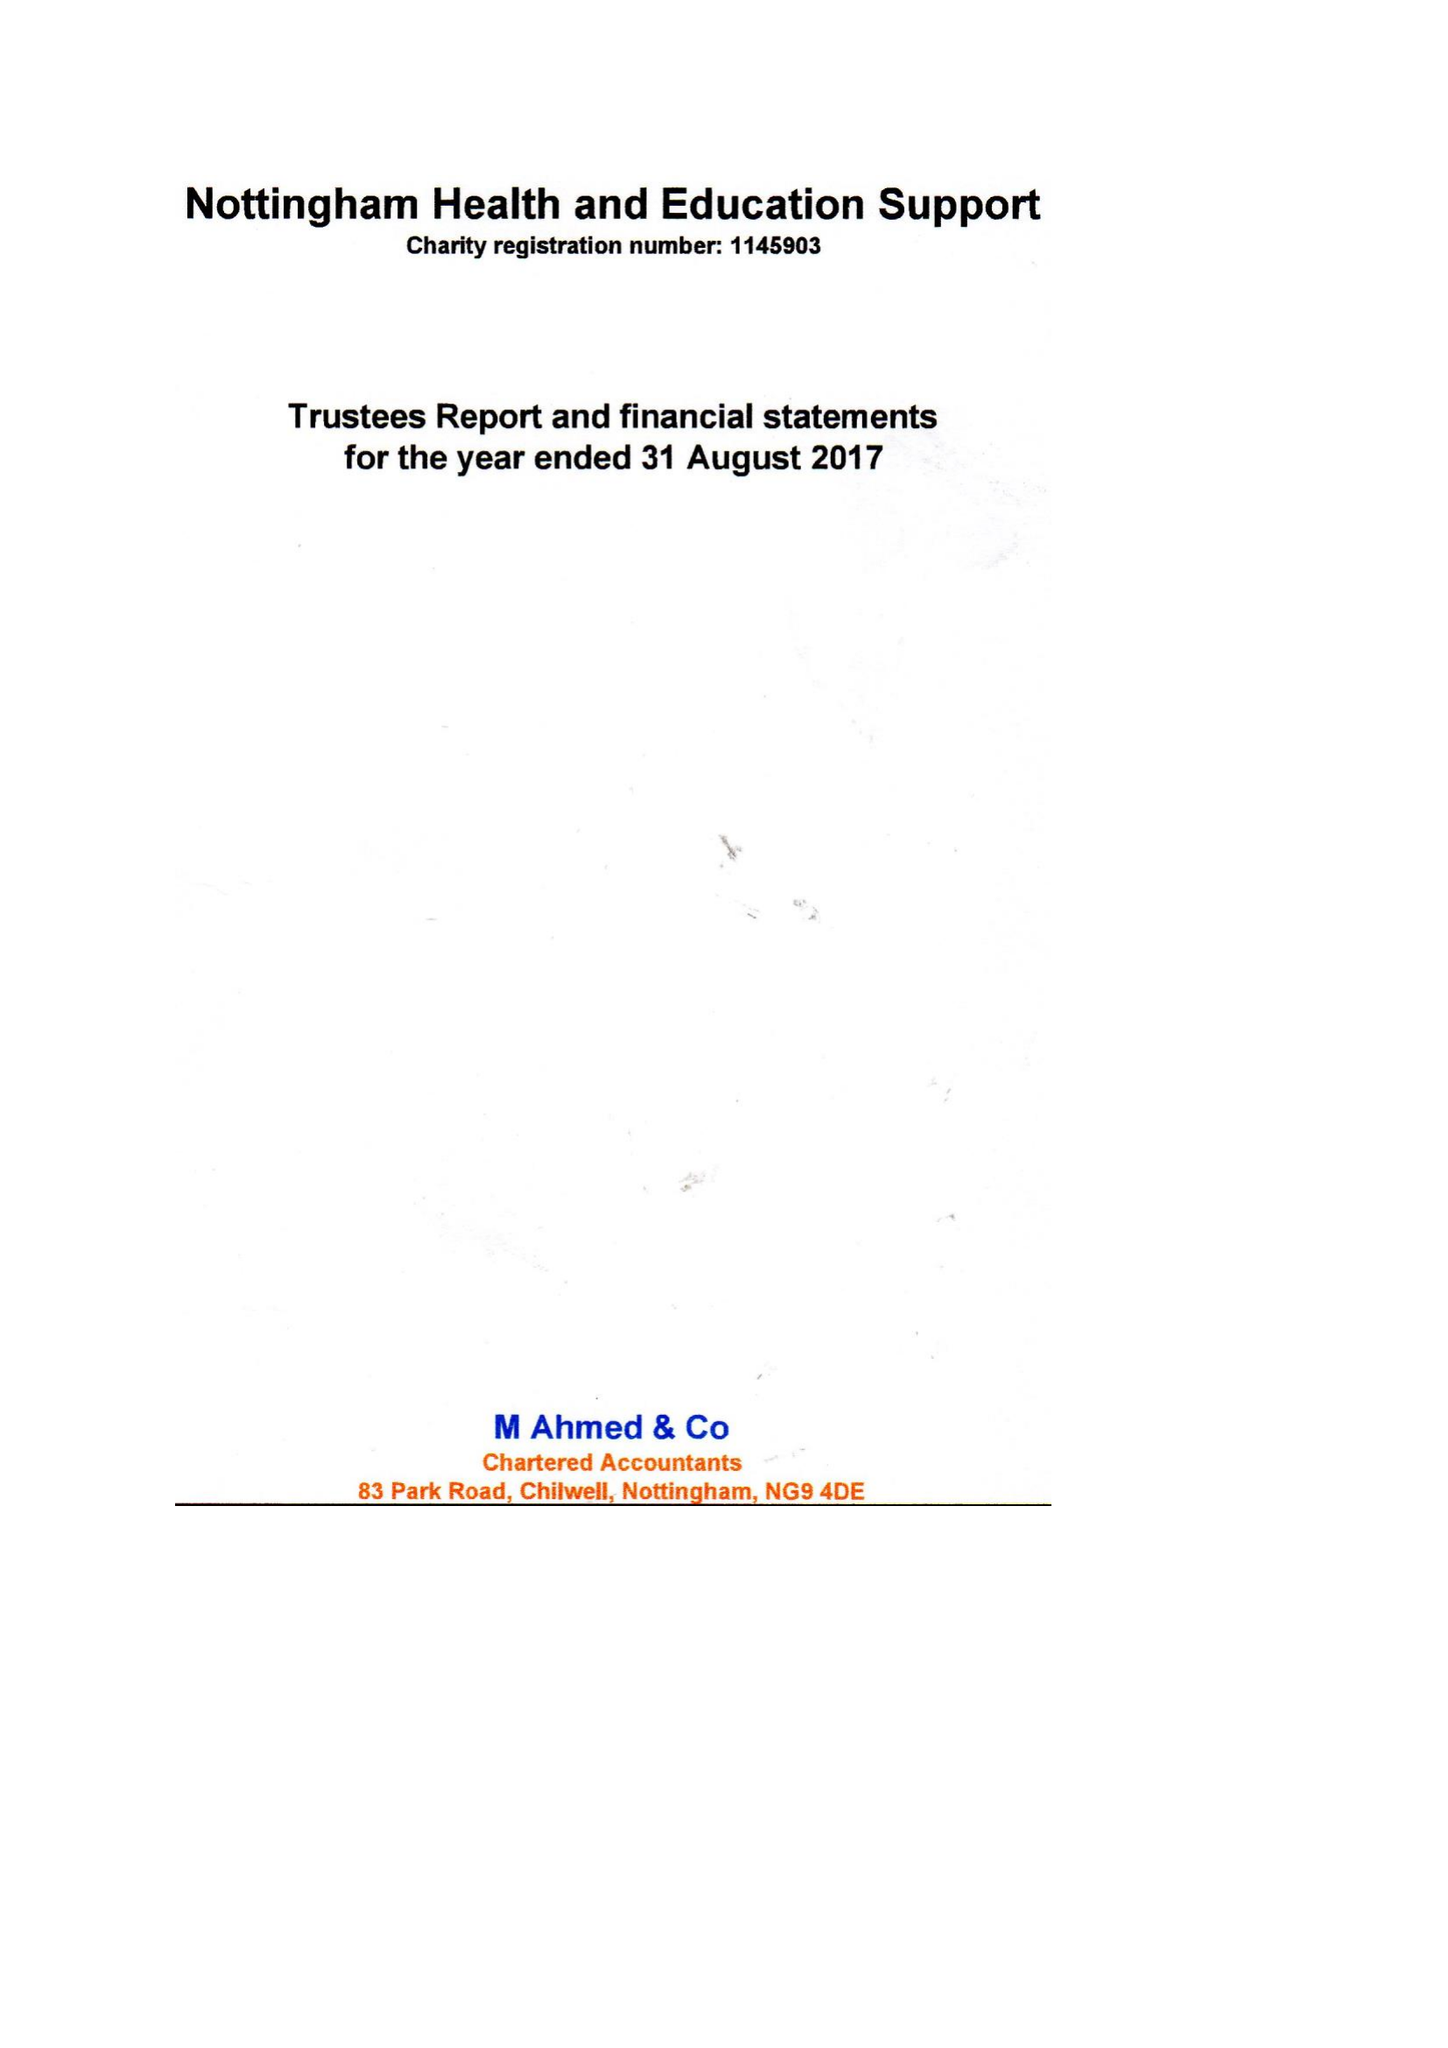What is the value for the charity_name?
Answer the question using a single word or phrase. Nottingham Health and Education Support 